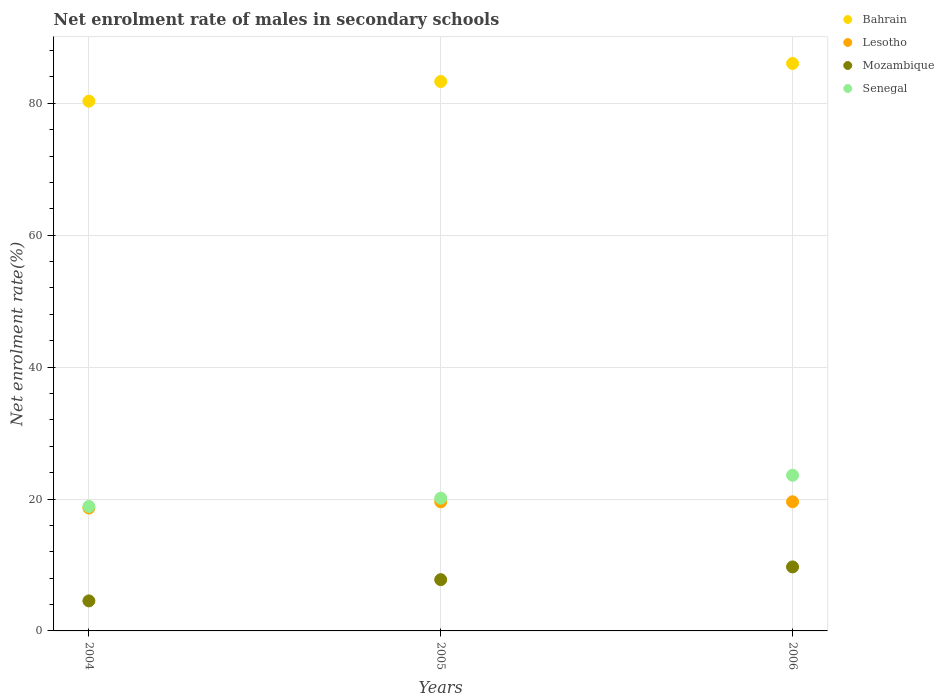How many different coloured dotlines are there?
Keep it short and to the point. 4. Is the number of dotlines equal to the number of legend labels?
Give a very brief answer. Yes. What is the net enrolment rate of males in secondary schools in Mozambique in 2006?
Offer a very short reply. 9.7. Across all years, what is the maximum net enrolment rate of males in secondary schools in Mozambique?
Offer a very short reply. 9.7. Across all years, what is the minimum net enrolment rate of males in secondary schools in Bahrain?
Your answer should be compact. 80.31. In which year was the net enrolment rate of males in secondary schools in Senegal maximum?
Your answer should be very brief. 2006. In which year was the net enrolment rate of males in secondary schools in Lesotho minimum?
Provide a succinct answer. 2004. What is the total net enrolment rate of males in secondary schools in Bahrain in the graph?
Your answer should be very brief. 249.64. What is the difference between the net enrolment rate of males in secondary schools in Senegal in 2004 and that in 2005?
Your response must be concise. -1.25. What is the difference between the net enrolment rate of males in secondary schools in Mozambique in 2006 and the net enrolment rate of males in secondary schools in Lesotho in 2004?
Keep it short and to the point. -8.93. What is the average net enrolment rate of males in secondary schools in Bahrain per year?
Your answer should be very brief. 83.21. In the year 2004, what is the difference between the net enrolment rate of males in secondary schools in Bahrain and net enrolment rate of males in secondary schools in Lesotho?
Your answer should be very brief. 61.68. In how many years, is the net enrolment rate of males in secondary schools in Mozambique greater than 80 %?
Make the answer very short. 0. What is the ratio of the net enrolment rate of males in secondary schools in Senegal in 2004 to that in 2005?
Your answer should be very brief. 0.94. Is the net enrolment rate of males in secondary schools in Bahrain in 2004 less than that in 2005?
Offer a very short reply. Yes. What is the difference between the highest and the second highest net enrolment rate of males in secondary schools in Lesotho?
Keep it short and to the point. 0.01. What is the difference between the highest and the lowest net enrolment rate of males in secondary schools in Senegal?
Ensure brevity in your answer.  4.73. In how many years, is the net enrolment rate of males in secondary schools in Mozambique greater than the average net enrolment rate of males in secondary schools in Mozambique taken over all years?
Provide a short and direct response. 2. Is it the case that in every year, the sum of the net enrolment rate of males in secondary schools in Mozambique and net enrolment rate of males in secondary schools in Lesotho  is greater than the net enrolment rate of males in secondary schools in Senegal?
Your answer should be compact. Yes. How many dotlines are there?
Ensure brevity in your answer.  4. What is the difference between two consecutive major ticks on the Y-axis?
Your response must be concise. 20. Does the graph contain grids?
Provide a succinct answer. Yes. How many legend labels are there?
Make the answer very short. 4. What is the title of the graph?
Provide a succinct answer. Net enrolment rate of males in secondary schools. What is the label or title of the X-axis?
Offer a very short reply. Years. What is the label or title of the Y-axis?
Make the answer very short. Net enrolment rate(%). What is the Net enrolment rate(%) in Bahrain in 2004?
Make the answer very short. 80.31. What is the Net enrolment rate(%) in Lesotho in 2004?
Offer a very short reply. 18.63. What is the Net enrolment rate(%) of Mozambique in 2004?
Make the answer very short. 4.55. What is the Net enrolment rate(%) of Senegal in 2004?
Make the answer very short. 18.87. What is the Net enrolment rate(%) of Bahrain in 2005?
Keep it short and to the point. 83.3. What is the Net enrolment rate(%) in Lesotho in 2005?
Ensure brevity in your answer.  19.57. What is the Net enrolment rate(%) in Mozambique in 2005?
Keep it short and to the point. 7.77. What is the Net enrolment rate(%) in Senegal in 2005?
Make the answer very short. 20.13. What is the Net enrolment rate(%) in Bahrain in 2006?
Provide a short and direct response. 86.03. What is the Net enrolment rate(%) of Lesotho in 2006?
Give a very brief answer. 19.58. What is the Net enrolment rate(%) in Mozambique in 2006?
Offer a terse response. 9.7. What is the Net enrolment rate(%) of Senegal in 2006?
Offer a terse response. 23.6. Across all years, what is the maximum Net enrolment rate(%) in Bahrain?
Your response must be concise. 86.03. Across all years, what is the maximum Net enrolment rate(%) in Lesotho?
Give a very brief answer. 19.58. Across all years, what is the maximum Net enrolment rate(%) of Mozambique?
Your response must be concise. 9.7. Across all years, what is the maximum Net enrolment rate(%) of Senegal?
Your response must be concise. 23.6. Across all years, what is the minimum Net enrolment rate(%) of Bahrain?
Provide a short and direct response. 80.31. Across all years, what is the minimum Net enrolment rate(%) in Lesotho?
Give a very brief answer. 18.63. Across all years, what is the minimum Net enrolment rate(%) of Mozambique?
Give a very brief answer. 4.55. Across all years, what is the minimum Net enrolment rate(%) in Senegal?
Your answer should be very brief. 18.87. What is the total Net enrolment rate(%) in Bahrain in the graph?
Offer a terse response. 249.64. What is the total Net enrolment rate(%) in Lesotho in the graph?
Make the answer very short. 57.78. What is the total Net enrolment rate(%) of Mozambique in the graph?
Provide a succinct answer. 22.03. What is the total Net enrolment rate(%) of Senegal in the graph?
Your answer should be compact. 62.6. What is the difference between the Net enrolment rate(%) of Bahrain in 2004 and that in 2005?
Make the answer very short. -2.98. What is the difference between the Net enrolment rate(%) in Lesotho in 2004 and that in 2005?
Provide a short and direct response. -0.94. What is the difference between the Net enrolment rate(%) in Mozambique in 2004 and that in 2005?
Ensure brevity in your answer.  -3.22. What is the difference between the Net enrolment rate(%) in Senegal in 2004 and that in 2005?
Provide a short and direct response. -1.25. What is the difference between the Net enrolment rate(%) in Bahrain in 2004 and that in 2006?
Your answer should be very brief. -5.72. What is the difference between the Net enrolment rate(%) of Lesotho in 2004 and that in 2006?
Your answer should be very brief. -0.95. What is the difference between the Net enrolment rate(%) in Mozambique in 2004 and that in 2006?
Provide a short and direct response. -5.15. What is the difference between the Net enrolment rate(%) of Senegal in 2004 and that in 2006?
Your answer should be compact. -4.73. What is the difference between the Net enrolment rate(%) in Bahrain in 2005 and that in 2006?
Ensure brevity in your answer.  -2.74. What is the difference between the Net enrolment rate(%) of Lesotho in 2005 and that in 2006?
Your answer should be very brief. -0.01. What is the difference between the Net enrolment rate(%) in Mozambique in 2005 and that in 2006?
Give a very brief answer. -1.93. What is the difference between the Net enrolment rate(%) of Senegal in 2005 and that in 2006?
Keep it short and to the point. -3.47. What is the difference between the Net enrolment rate(%) in Bahrain in 2004 and the Net enrolment rate(%) in Lesotho in 2005?
Offer a terse response. 60.74. What is the difference between the Net enrolment rate(%) in Bahrain in 2004 and the Net enrolment rate(%) in Mozambique in 2005?
Ensure brevity in your answer.  72.54. What is the difference between the Net enrolment rate(%) of Bahrain in 2004 and the Net enrolment rate(%) of Senegal in 2005?
Keep it short and to the point. 60.19. What is the difference between the Net enrolment rate(%) of Lesotho in 2004 and the Net enrolment rate(%) of Mozambique in 2005?
Give a very brief answer. 10.86. What is the difference between the Net enrolment rate(%) of Lesotho in 2004 and the Net enrolment rate(%) of Senegal in 2005?
Provide a succinct answer. -1.49. What is the difference between the Net enrolment rate(%) in Mozambique in 2004 and the Net enrolment rate(%) in Senegal in 2005?
Offer a terse response. -15.57. What is the difference between the Net enrolment rate(%) of Bahrain in 2004 and the Net enrolment rate(%) of Lesotho in 2006?
Offer a terse response. 60.73. What is the difference between the Net enrolment rate(%) of Bahrain in 2004 and the Net enrolment rate(%) of Mozambique in 2006?
Provide a succinct answer. 70.61. What is the difference between the Net enrolment rate(%) of Bahrain in 2004 and the Net enrolment rate(%) of Senegal in 2006?
Your response must be concise. 56.71. What is the difference between the Net enrolment rate(%) in Lesotho in 2004 and the Net enrolment rate(%) in Mozambique in 2006?
Offer a very short reply. 8.93. What is the difference between the Net enrolment rate(%) of Lesotho in 2004 and the Net enrolment rate(%) of Senegal in 2006?
Offer a very short reply. -4.97. What is the difference between the Net enrolment rate(%) of Mozambique in 2004 and the Net enrolment rate(%) of Senegal in 2006?
Offer a terse response. -19.05. What is the difference between the Net enrolment rate(%) in Bahrain in 2005 and the Net enrolment rate(%) in Lesotho in 2006?
Give a very brief answer. 63.72. What is the difference between the Net enrolment rate(%) in Bahrain in 2005 and the Net enrolment rate(%) in Mozambique in 2006?
Make the answer very short. 73.59. What is the difference between the Net enrolment rate(%) in Bahrain in 2005 and the Net enrolment rate(%) in Senegal in 2006?
Ensure brevity in your answer.  59.7. What is the difference between the Net enrolment rate(%) in Lesotho in 2005 and the Net enrolment rate(%) in Mozambique in 2006?
Offer a very short reply. 9.87. What is the difference between the Net enrolment rate(%) of Lesotho in 2005 and the Net enrolment rate(%) of Senegal in 2006?
Provide a succinct answer. -4.03. What is the difference between the Net enrolment rate(%) in Mozambique in 2005 and the Net enrolment rate(%) in Senegal in 2006?
Offer a terse response. -15.83. What is the average Net enrolment rate(%) in Bahrain per year?
Ensure brevity in your answer.  83.21. What is the average Net enrolment rate(%) in Lesotho per year?
Offer a terse response. 19.26. What is the average Net enrolment rate(%) of Mozambique per year?
Keep it short and to the point. 7.34. What is the average Net enrolment rate(%) in Senegal per year?
Make the answer very short. 20.87. In the year 2004, what is the difference between the Net enrolment rate(%) of Bahrain and Net enrolment rate(%) of Lesotho?
Your answer should be very brief. 61.68. In the year 2004, what is the difference between the Net enrolment rate(%) of Bahrain and Net enrolment rate(%) of Mozambique?
Keep it short and to the point. 75.76. In the year 2004, what is the difference between the Net enrolment rate(%) in Bahrain and Net enrolment rate(%) in Senegal?
Your response must be concise. 61.44. In the year 2004, what is the difference between the Net enrolment rate(%) in Lesotho and Net enrolment rate(%) in Mozambique?
Your answer should be compact. 14.08. In the year 2004, what is the difference between the Net enrolment rate(%) of Lesotho and Net enrolment rate(%) of Senegal?
Provide a succinct answer. -0.24. In the year 2004, what is the difference between the Net enrolment rate(%) of Mozambique and Net enrolment rate(%) of Senegal?
Your response must be concise. -14.32. In the year 2005, what is the difference between the Net enrolment rate(%) in Bahrain and Net enrolment rate(%) in Lesotho?
Keep it short and to the point. 63.73. In the year 2005, what is the difference between the Net enrolment rate(%) of Bahrain and Net enrolment rate(%) of Mozambique?
Provide a short and direct response. 75.53. In the year 2005, what is the difference between the Net enrolment rate(%) in Bahrain and Net enrolment rate(%) in Senegal?
Your answer should be compact. 63.17. In the year 2005, what is the difference between the Net enrolment rate(%) in Lesotho and Net enrolment rate(%) in Mozambique?
Offer a terse response. 11.8. In the year 2005, what is the difference between the Net enrolment rate(%) of Lesotho and Net enrolment rate(%) of Senegal?
Ensure brevity in your answer.  -0.55. In the year 2005, what is the difference between the Net enrolment rate(%) of Mozambique and Net enrolment rate(%) of Senegal?
Make the answer very short. -12.35. In the year 2006, what is the difference between the Net enrolment rate(%) of Bahrain and Net enrolment rate(%) of Lesotho?
Provide a short and direct response. 66.45. In the year 2006, what is the difference between the Net enrolment rate(%) of Bahrain and Net enrolment rate(%) of Mozambique?
Ensure brevity in your answer.  76.33. In the year 2006, what is the difference between the Net enrolment rate(%) in Bahrain and Net enrolment rate(%) in Senegal?
Offer a very short reply. 62.43. In the year 2006, what is the difference between the Net enrolment rate(%) of Lesotho and Net enrolment rate(%) of Mozambique?
Make the answer very short. 9.88. In the year 2006, what is the difference between the Net enrolment rate(%) in Lesotho and Net enrolment rate(%) in Senegal?
Provide a short and direct response. -4.02. In the year 2006, what is the difference between the Net enrolment rate(%) in Mozambique and Net enrolment rate(%) in Senegal?
Your answer should be compact. -13.9. What is the ratio of the Net enrolment rate(%) of Bahrain in 2004 to that in 2005?
Your response must be concise. 0.96. What is the ratio of the Net enrolment rate(%) of Mozambique in 2004 to that in 2005?
Your response must be concise. 0.59. What is the ratio of the Net enrolment rate(%) in Senegal in 2004 to that in 2005?
Keep it short and to the point. 0.94. What is the ratio of the Net enrolment rate(%) of Bahrain in 2004 to that in 2006?
Provide a short and direct response. 0.93. What is the ratio of the Net enrolment rate(%) in Lesotho in 2004 to that in 2006?
Provide a succinct answer. 0.95. What is the ratio of the Net enrolment rate(%) of Mozambique in 2004 to that in 2006?
Your response must be concise. 0.47. What is the ratio of the Net enrolment rate(%) in Senegal in 2004 to that in 2006?
Offer a very short reply. 0.8. What is the ratio of the Net enrolment rate(%) in Bahrain in 2005 to that in 2006?
Your answer should be compact. 0.97. What is the ratio of the Net enrolment rate(%) in Lesotho in 2005 to that in 2006?
Your response must be concise. 1. What is the ratio of the Net enrolment rate(%) of Mozambique in 2005 to that in 2006?
Keep it short and to the point. 0.8. What is the ratio of the Net enrolment rate(%) of Senegal in 2005 to that in 2006?
Provide a succinct answer. 0.85. What is the difference between the highest and the second highest Net enrolment rate(%) in Bahrain?
Your response must be concise. 2.74. What is the difference between the highest and the second highest Net enrolment rate(%) of Lesotho?
Offer a very short reply. 0.01. What is the difference between the highest and the second highest Net enrolment rate(%) in Mozambique?
Keep it short and to the point. 1.93. What is the difference between the highest and the second highest Net enrolment rate(%) in Senegal?
Provide a short and direct response. 3.47. What is the difference between the highest and the lowest Net enrolment rate(%) in Bahrain?
Make the answer very short. 5.72. What is the difference between the highest and the lowest Net enrolment rate(%) in Lesotho?
Provide a succinct answer. 0.95. What is the difference between the highest and the lowest Net enrolment rate(%) of Mozambique?
Give a very brief answer. 5.15. What is the difference between the highest and the lowest Net enrolment rate(%) of Senegal?
Your answer should be compact. 4.73. 